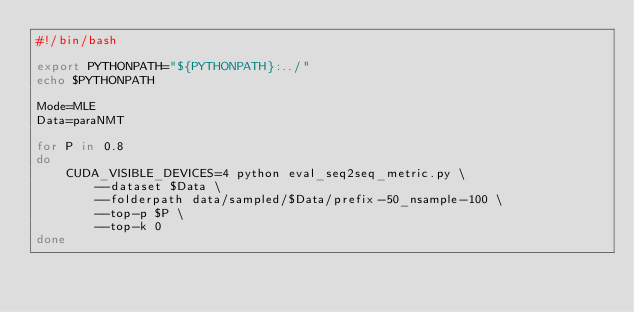Convert code to text. <code><loc_0><loc_0><loc_500><loc_500><_Bash_>#!/bin/bash

export PYTHONPATH="${PYTHONPATH}:../"
echo $PYTHONPATH

Mode=MLE
Data=paraNMT

for P in 0.8
do
    CUDA_VISIBLE_DEVICES=4 python eval_seq2seq_metric.py \
        --dataset $Data \
        --folderpath data/sampled/$Data/prefix-50_nsample-100 \
        --top-p $P \
        --top-k 0
done</code> 